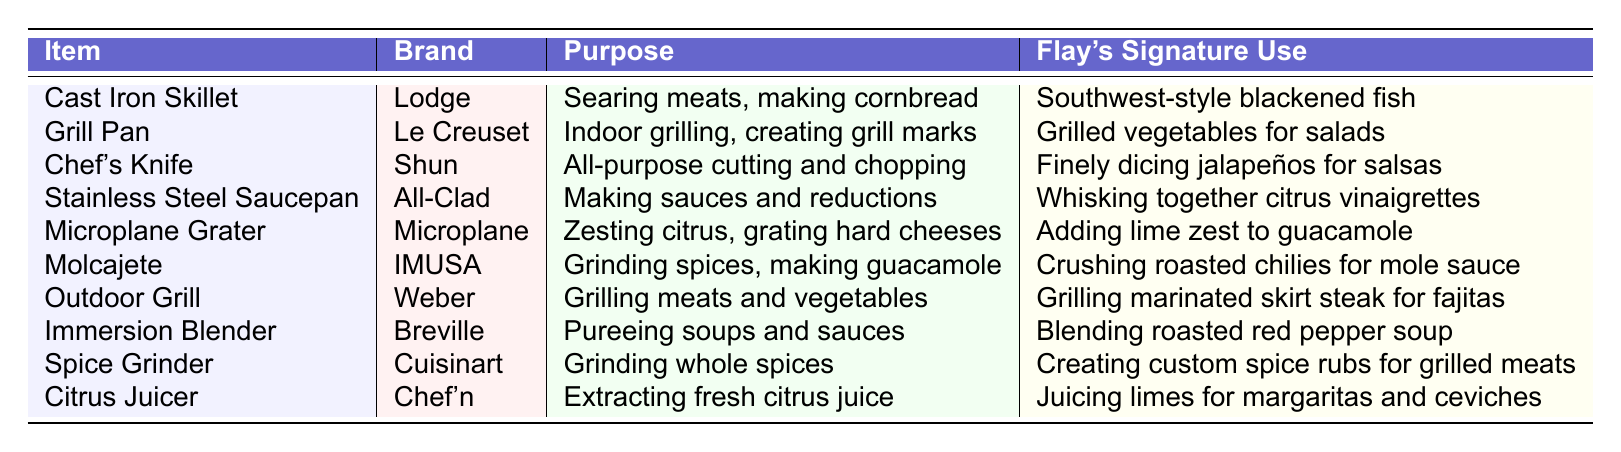What is the purpose of the Molcajete? From the table, the Molcajete's purpose is indicated as "Grinding spices, making guacamole."
Answer: Grinding spices, making guacamole Which brand is associated with the Chef's Knife? The table states that the brand associated with the Chef's Knife is "Shun."
Answer: Shun What is Flay's signature use for the Outdoor Grill? According to the table, Flay's signature use for the Outdoor Grill is "Grilling marinated skirt steak for fajitas."
Answer: Grilling marinated skirt steak for fajitas Can the Immersion Blender be used for making sauces? Yes, the table lists the purpose of the Immersion Blender as "Pureeing soups and sauces," indicating it can be used for sauces.
Answer: Yes Which item has a signature use of adding lime zest to guacamole? By reviewing the table, the item with a signature use of adding lime zest to guacamole is the "Microplane Grater."
Answer: Microplane Grater Is the purpose of the Citrus Juicer to grind whole spices? The table lists the purpose of the Citrus Juicer as "Extracting fresh citrus juice," so it does not grind spices.
Answer: No How many items are specifically described for making sauces? The table mentions two items with purposes related to making sauces: the "Stainless Steel Saucepan" and the "Immersion Blender." Therefore, there are 2 items.
Answer: 2 What are the signature uses of the equipment that relates to grilling? The Outdoor Grill is used for "Grilling marinated skirt steak for fajitas," and the Grill Pan is used for "Grilled vegetables for salads," showing both have grilling-related uses.
Answer: Outdoor Grill: Grilling marinated skirt steak for fajitas, Grill Pan: Grilled vegetables for salads Which brand is used for the Microplane Grater? The table indicates that the brand associated with the Microplane Grater is "Microplane."
Answer: Microplane What is the difference in purpose between the Cast Iron Skillet and the Stainless Steel Saucepan? The Cast Iron Skillet is for "Searing meats, making cornbread," while the Stainless Steel Saucepan is for "Making sauces and reductions," indicating different culinary uses.
Answer: Searing meats vs. making sauces 